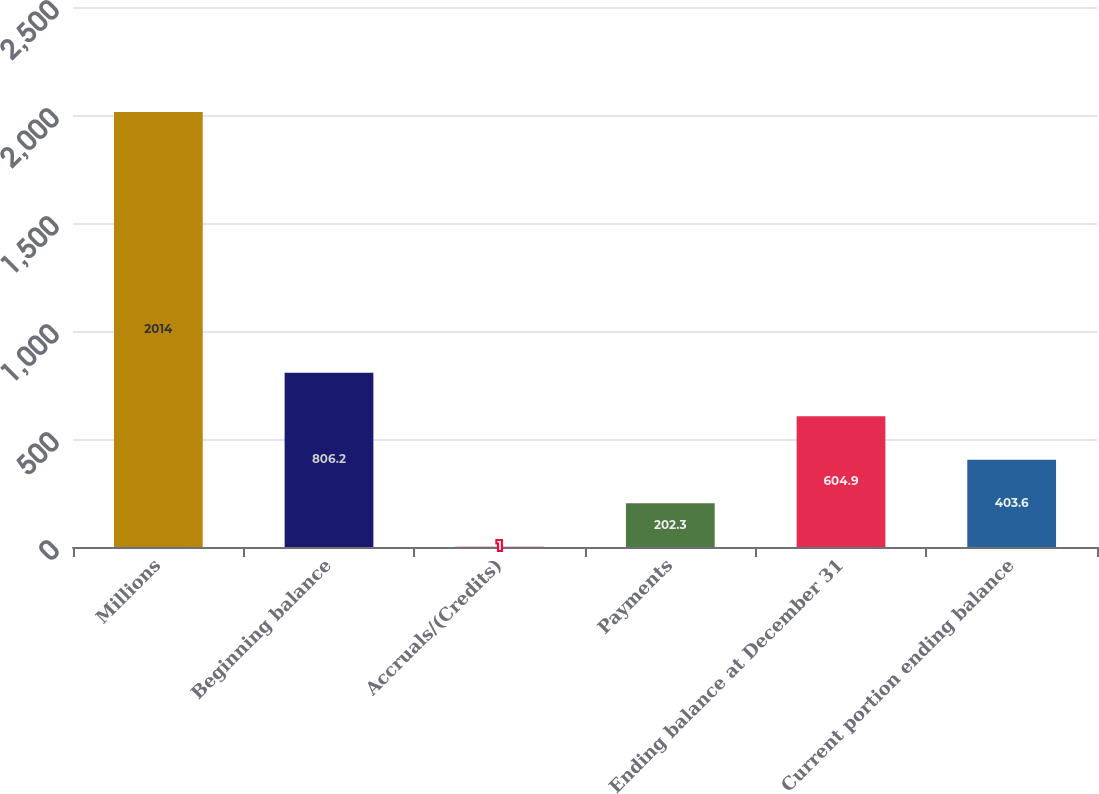Convert chart to OTSL. <chart><loc_0><loc_0><loc_500><loc_500><bar_chart><fcel>Millions<fcel>Beginning balance<fcel>Accruals/(Credits)<fcel>Payments<fcel>Ending balance at December 31<fcel>Current portion ending balance<nl><fcel>2014<fcel>806.2<fcel>1<fcel>202.3<fcel>604.9<fcel>403.6<nl></chart> 